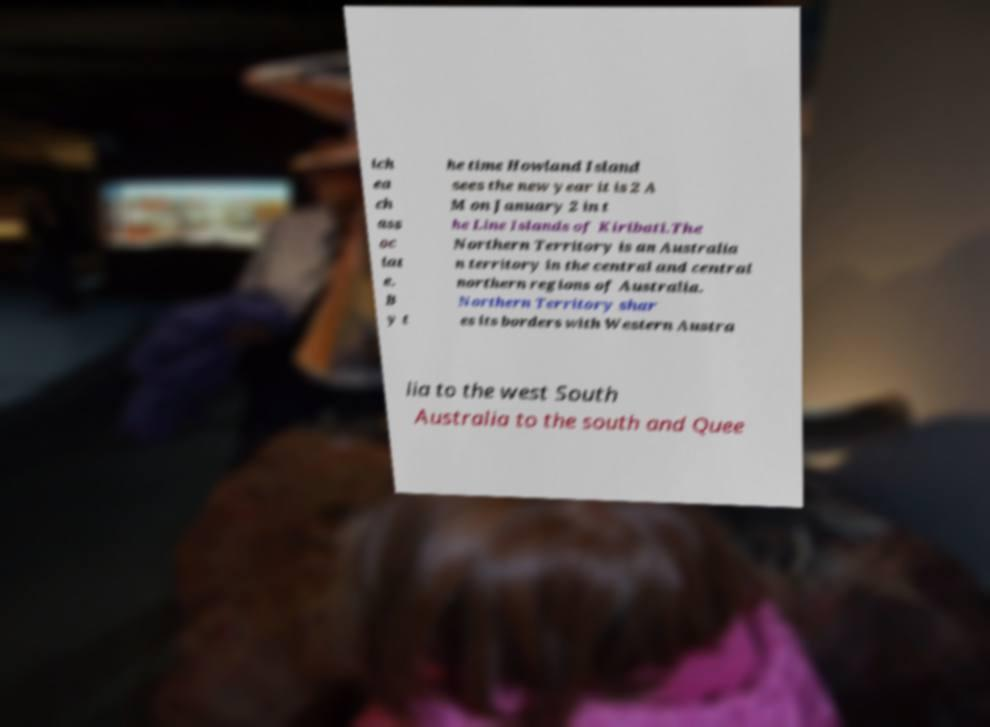What messages or text are displayed in this image? I need them in a readable, typed format. ich ea ch ass oc iat e. B y t he time Howland Island sees the new year it is 2 A M on January 2 in t he Line Islands of Kiribati.The Northern Territory is an Australia n territory in the central and central northern regions of Australia. Northern Territory shar es its borders with Western Austra lia to the west South Australia to the south and Quee 